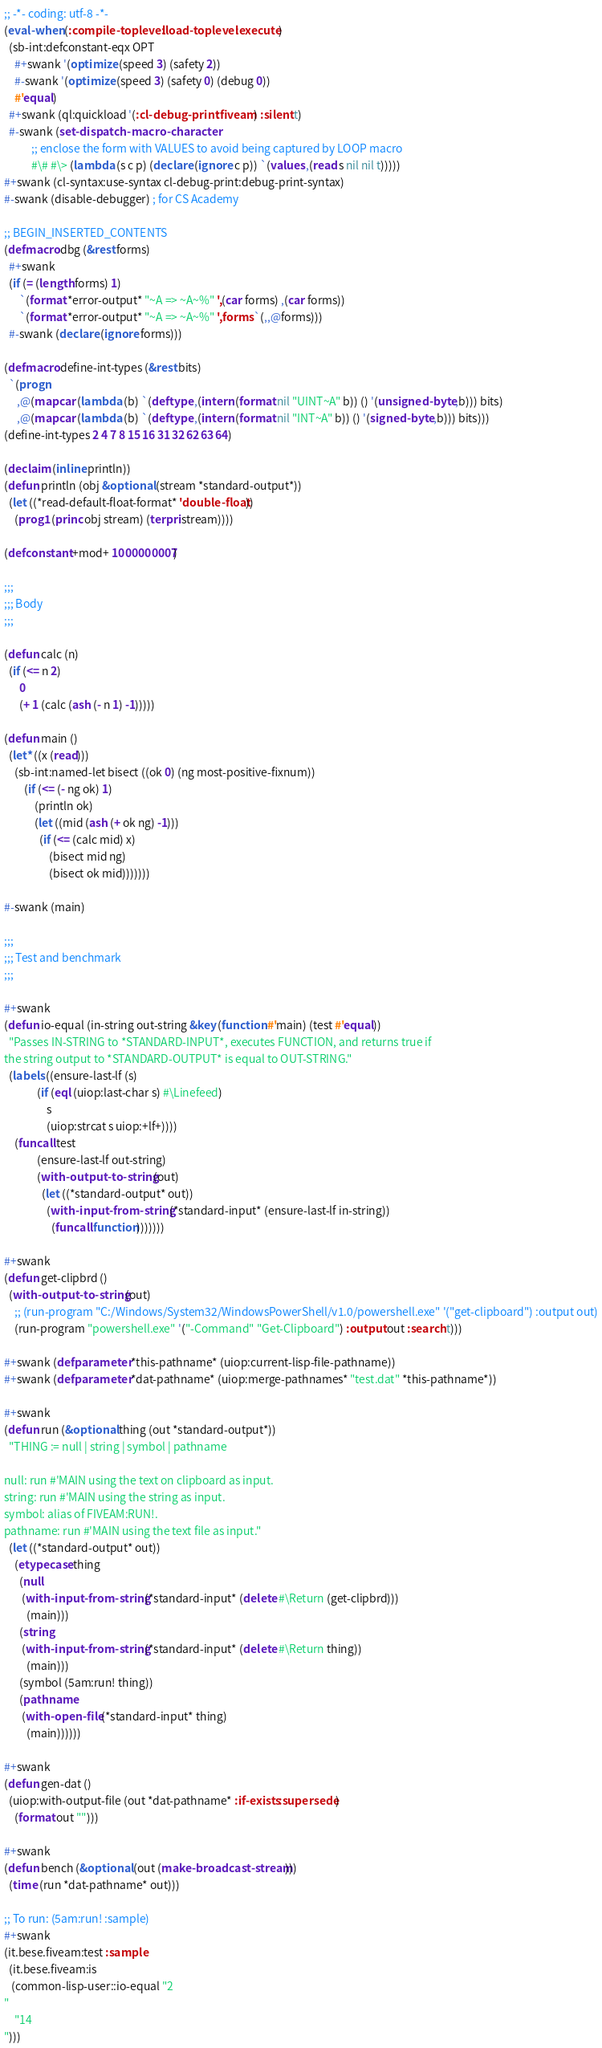<code> <loc_0><loc_0><loc_500><loc_500><_Lisp_>;; -*- coding: utf-8 -*-
(eval-when (:compile-toplevel :load-toplevel :execute)
  (sb-int:defconstant-eqx OPT
    #+swank '(optimize (speed 3) (safety 2))
    #-swank '(optimize (speed 3) (safety 0) (debug 0))
    #'equal)
  #+swank (ql:quickload '(:cl-debug-print :fiveam) :silent t)
  #-swank (set-dispatch-macro-character
           ;; enclose the form with VALUES to avoid being captured by LOOP macro
           #\# #\> (lambda (s c p) (declare (ignore c p)) `(values ,(read s nil nil t)))))
#+swank (cl-syntax:use-syntax cl-debug-print:debug-print-syntax)
#-swank (disable-debugger) ; for CS Academy

;; BEGIN_INSERTED_CONTENTS
(defmacro dbg (&rest forms)
  #+swank
  (if (= (length forms) 1)
      `(format *error-output* "~A => ~A~%" ',(car forms) ,(car forms))
      `(format *error-output* "~A => ~A~%" ',forms `(,,@forms)))
  #-swank (declare (ignore forms)))

(defmacro define-int-types (&rest bits)
  `(progn
     ,@(mapcar (lambda (b) `(deftype ,(intern (format nil "UINT~A" b)) () '(unsigned-byte ,b))) bits)
     ,@(mapcar (lambda (b) `(deftype ,(intern (format nil "INT~A" b)) () '(signed-byte ,b))) bits)))
(define-int-types 2 4 7 8 15 16 31 32 62 63 64)

(declaim (inline println))
(defun println (obj &optional (stream *standard-output*))
  (let ((*read-default-float-format* 'double-float))
    (prog1 (princ obj stream) (terpri stream))))

(defconstant +mod+ 1000000007)

;;;
;;; Body
;;;

(defun calc (n)
  (if (<= n 2)
      0
      (+ 1 (calc (ash (- n 1) -1)))))

(defun main ()
  (let* ((x (read)))
    (sb-int:named-let bisect ((ok 0) (ng most-positive-fixnum))
        (if (<= (- ng ok) 1)
            (println ok)
            (let ((mid (ash (+ ok ng) -1)))
              (if (<= (calc mid) x)
                  (bisect mid ng)
                  (bisect ok mid)))))))

#-swank (main)

;;;
;;; Test and benchmark
;;;

#+swank
(defun io-equal (in-string out-string &key (function #'main) (test #'equal))
  "Passes IN-STRING to *STANDARD-INPUT*, executes FUNCTION, and returns true if
the string output to *STANDARD-OUTPUT* is equal to OUT-STRING."
  (labels ((ensure-last-lf (s)
             (if (eql (uiop:last-char s) #\Linefeed)
                 s
                 (uiop:strcat s uiop:+lf+))))
    (funcall test
             (ensure-last-lf out-string)
             (with-output-to-string (out)
               (let ((*standard-output* out))
                 (with-input-from-string (*standard-input* (ensure-last-lf in-string))
                   (funcall function)))))))

#+swank
(defun get-clipbrd ()
  (with-output-to-string (out)
    ;; (run-program "C:/Windows/System32/WindowsPowerShell/v1.0/powershell.exe" '("get-clipboard") :output out)
    (run-program "powershell.exe" '("-Command" "Get-Clipboard") :output out :search t)))

#+swank (defparameter *this-pathname* (uiop:current-lisp-file-pathname))
#+swank (defparameter *dat-pathname* (uiop:merge-pathnames* "test.dat" *this-pathname*))

#+swank
(defun run (&optional thing (out *standard-output*))
  "THING := null | string | symbol | pathname

null: run #'MAIN using the text on clipboard as input.
string: run #'MAIN using the string as input.
symbol: alias of FIVEAM:RUN!.
pathname: run #'MAIN using the text file as input."
  (let ((*standard-output* out))
    (etypecase thing
      (null
       (with-input-from-string (*standard-input* (delete #\Return (get-clipbrd)))
         (main)))
      (string
       (with-input-from-string (*standard-input* (delete #\Return thing))
         (main)))
      (symbol (5am:run! thing))
      (pathname
       (with-open-file (*standard-input* thing)
         (main))))))

#+swank
(defun gen-dat ()
  (uiop:with-output-file (out *dat-pathname* :if-exists :supersede)
    (format out "")))

#+swank
(defun bench (&optional (out (make-broadcast-stream)))
  (time (run *dat-pathname* out)))

;; To run: (5am:run! :sample)
#+swank
(it.bese.fiveam:test :sample
  (it.bese.fiveam:is
   (common-lisp-user::io-equal "2
"
    "14
")))
</code> 